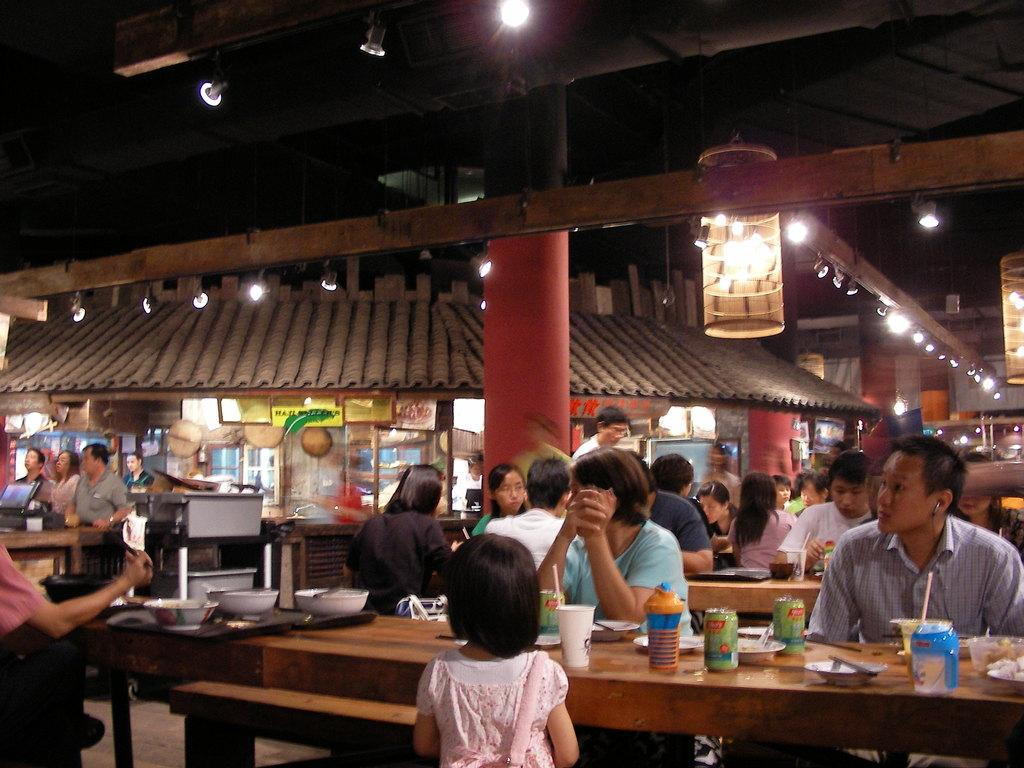What structure is visible in the image? There is a roof in the image. What can be used for illumination in the image? There is a light in the image. What are the people in the image doing? The people are sitting on chairs in the image. What is present for placing objects on in the image? There is a table in the image. What type of items can be seen on the table? There are bottles and a glass on the table. What type of boot can be seen hanging from the roof in the image? There is no boot present in the image; only a roof, light, people, chairs, table, bottles, and glass are visible. 